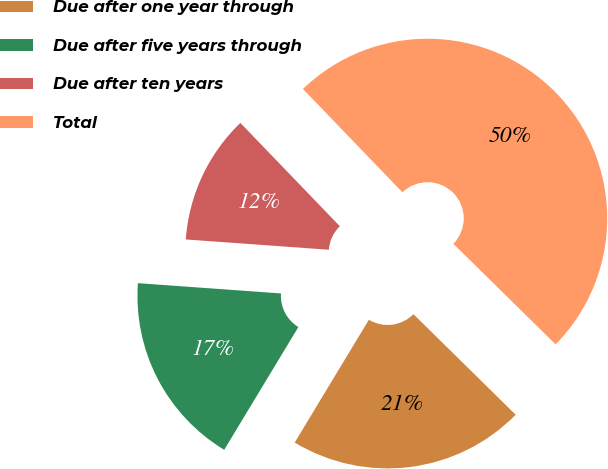Convert chart. <chart><loc_0><loc_0><loc_500><loc_500><pie_chart><fcel>Due after one year through<fcel>Due after five years through<fcel>Due after ten years<fcel>Total<nl><fcel>21.28%<fcel>17.49%<fcel>11.66%<fcel>49.56%<nl></chart> 